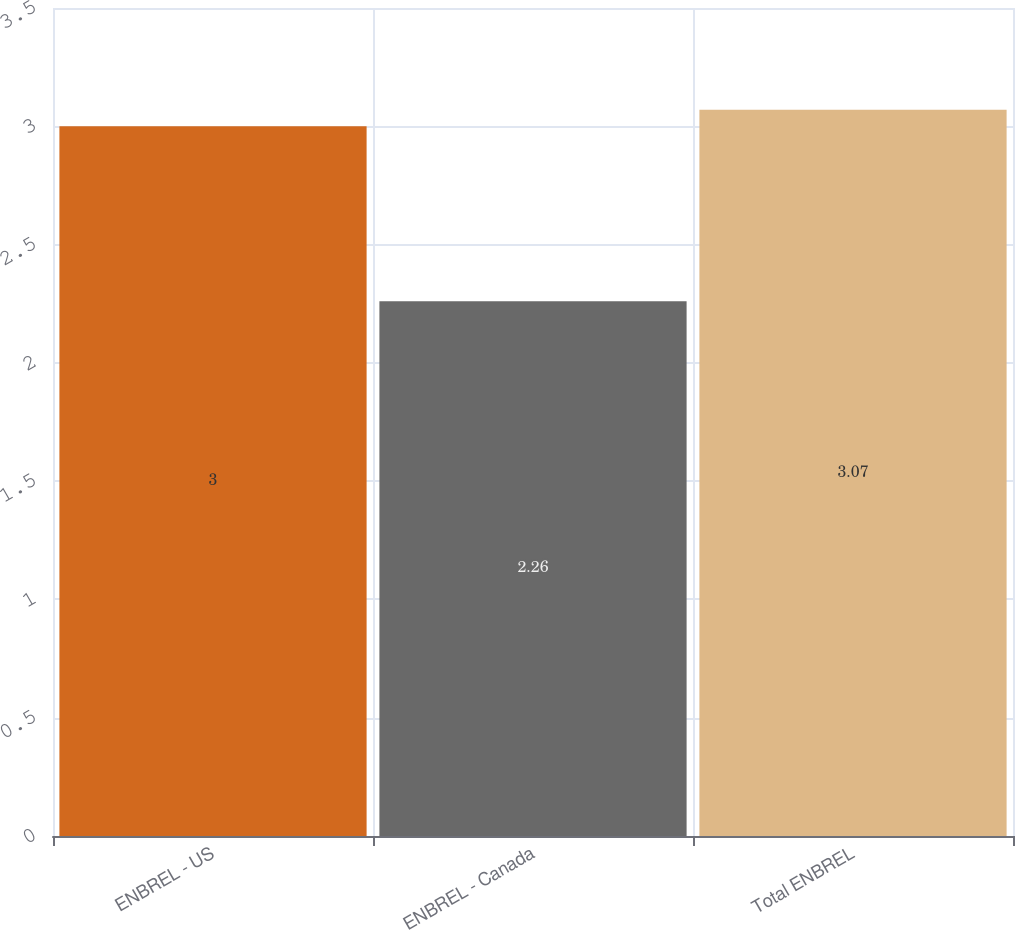Convert chart. <chart><loc_0><loc_0><loc_500><loc_500><bar_chart><fcel>ENBREL - US<fcel>ENBREL - Canada<fcel>Total ENBREL<nl><fcel>3<fcel>2.26<fcel>3.07<nl></chart> 